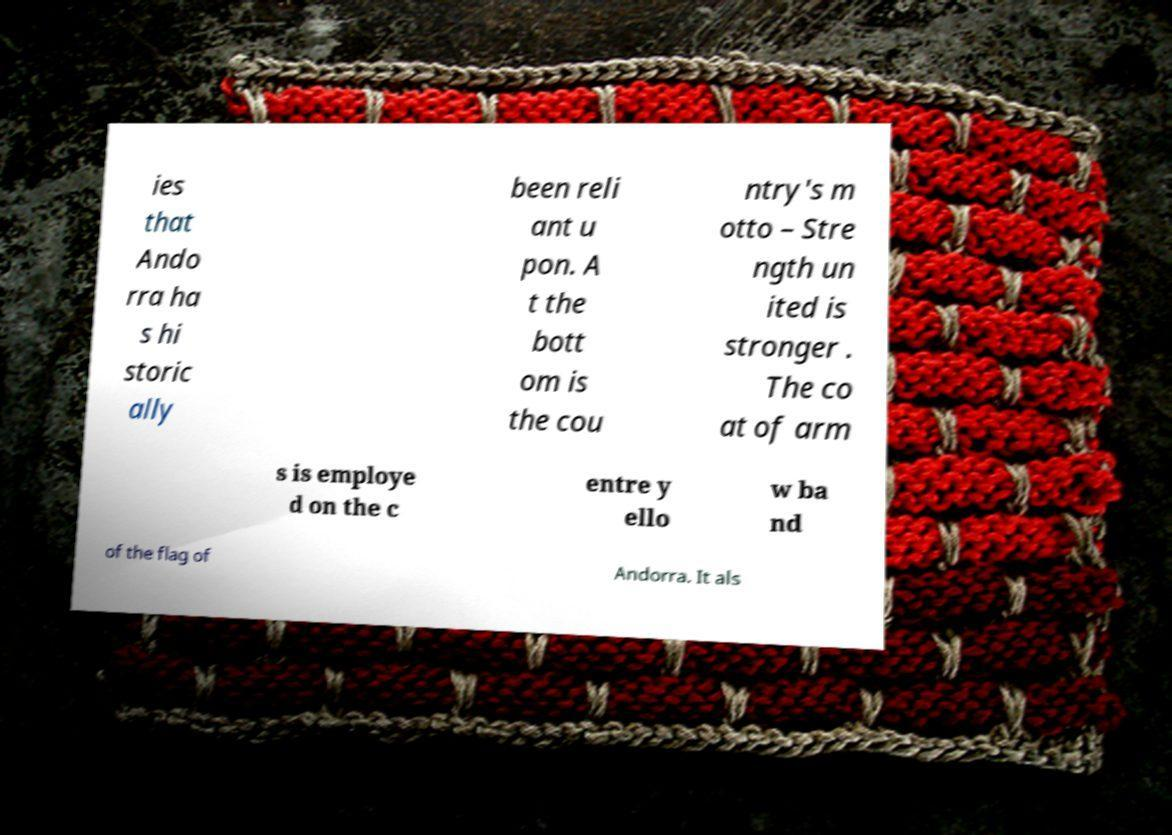Could you assist in decoding the text presented in this image and type it out clearly? ies that Ando rra ha s hi storic ally been reli ant u pon. A t the bott om is the cou ntry's m otto – Stre ngth un ited is stronger . The co at of arm s is employe d on the c entre y ello w ba nd of the flag of Andorra. It als 